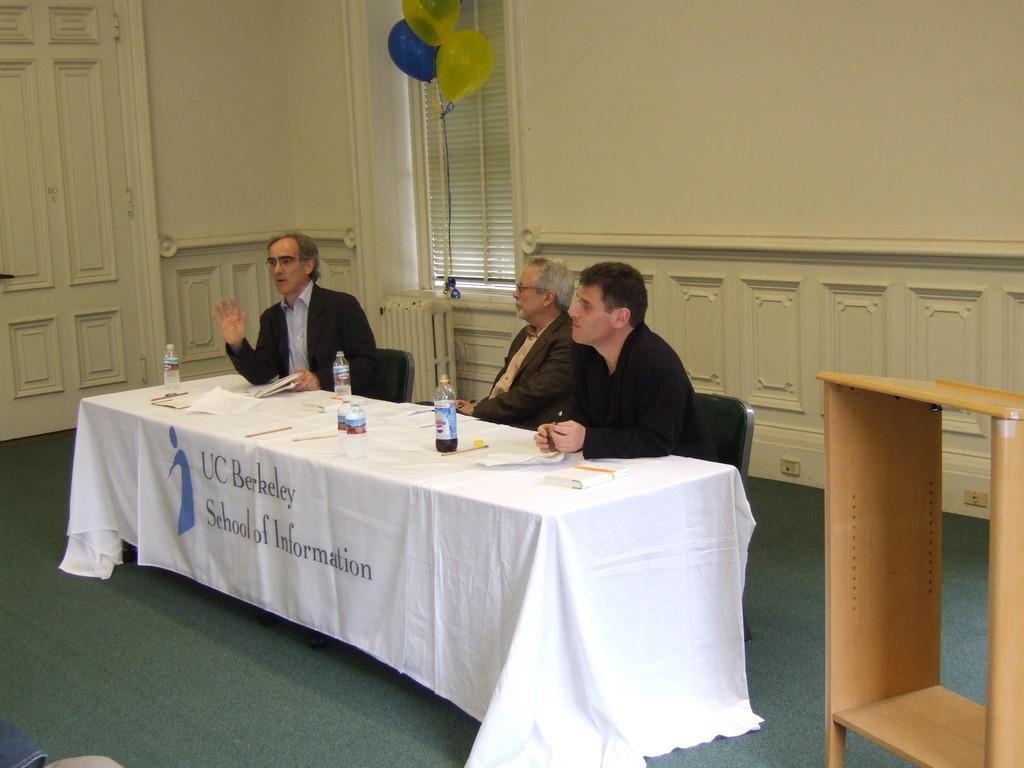Can you describe this image briefly? In this picture I can see people sitting on the chair. I can see the table. I can see wooden podium on the right side. I can see the door on the left side. I can see the Venetian blind window. 